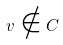<formula> <loc_0><loc_0><loc_500><loc_500>v \notin C</formula> 